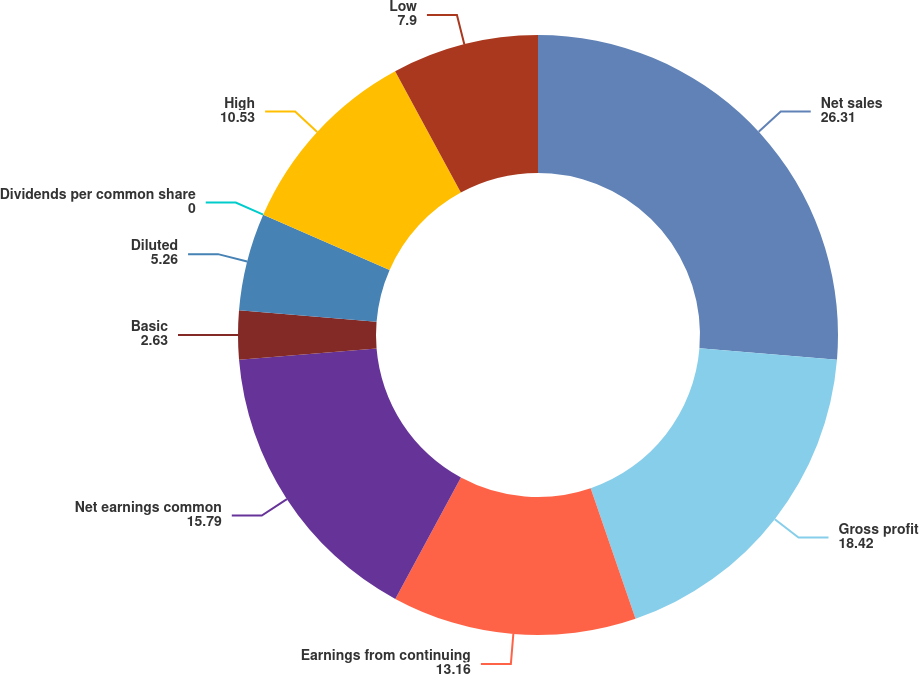Convert chart to OTSL. <chart><loc_0><loc_0><loc_500><loc_500><pie_chart><fcel>Net sales<fcel>Gross profit<fcel>Earnings from continuing<fcel>Net earnings common<fcel>Basic<fcel>Diluted<fcel>Dividends per common share<fcel>High<fcel>Low<nl><fcel>26.31%<fcel>18.42%<fcel>13.16%<fcel>15.79%<fcel>2.63%<fcel>5.26%<fcel>0.0%<fcel>10.53%<fcel>7.9%<nl></chart> 